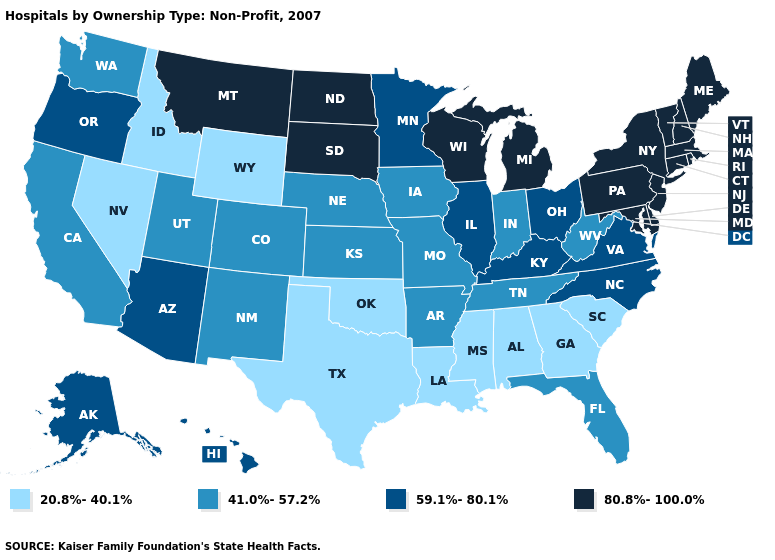Does Delaware have the highest value in the South?
Be succinct. Yes. Does Wyoming have the lowest value in the USA?
Keep it brief. Yes. Does the map have missing data?
Keep it brief. No. Among the states that border Kentucky , which have the highest value?
Give a very brief answer. Illinois, Ohio, Virginia. Does West Virginia have a lower value than New Jersey?
Short answer required. Yes. What is the value of Connecticut?
Write a very short answer. 80.8%-100.0%. Among the states that border New Jersey , which have the highest value?
Concise answer only. Delaware, New York, Pennsylvania. Does the first symbol in the legend represent the smallest category?
Concise answer only. Yes. Does Maryland have the lowest value in the South?
Quick response, please. No. What is the value of Missouri?
Quick response, please. 41.0%-57.2%. Does the first symbol in the legend represent the smallest category?
Quick response, please. Yes. Which states have the lowest value in the Northeast?
Give a very brief answer. Connecticut, Maine, Massachusetts, New Hampshire, New Jersey, New York, Pennsylvania, Rhode Island, Vermont. What is the lowest value in the USA?
Short answer required. 20.8%-40.1%. Does Mississippi have the lowest value in the South?
Answer briefly. Yes. What is the lowest value in the MidWest?
Concise answer only. 41.0%-57.2%. 